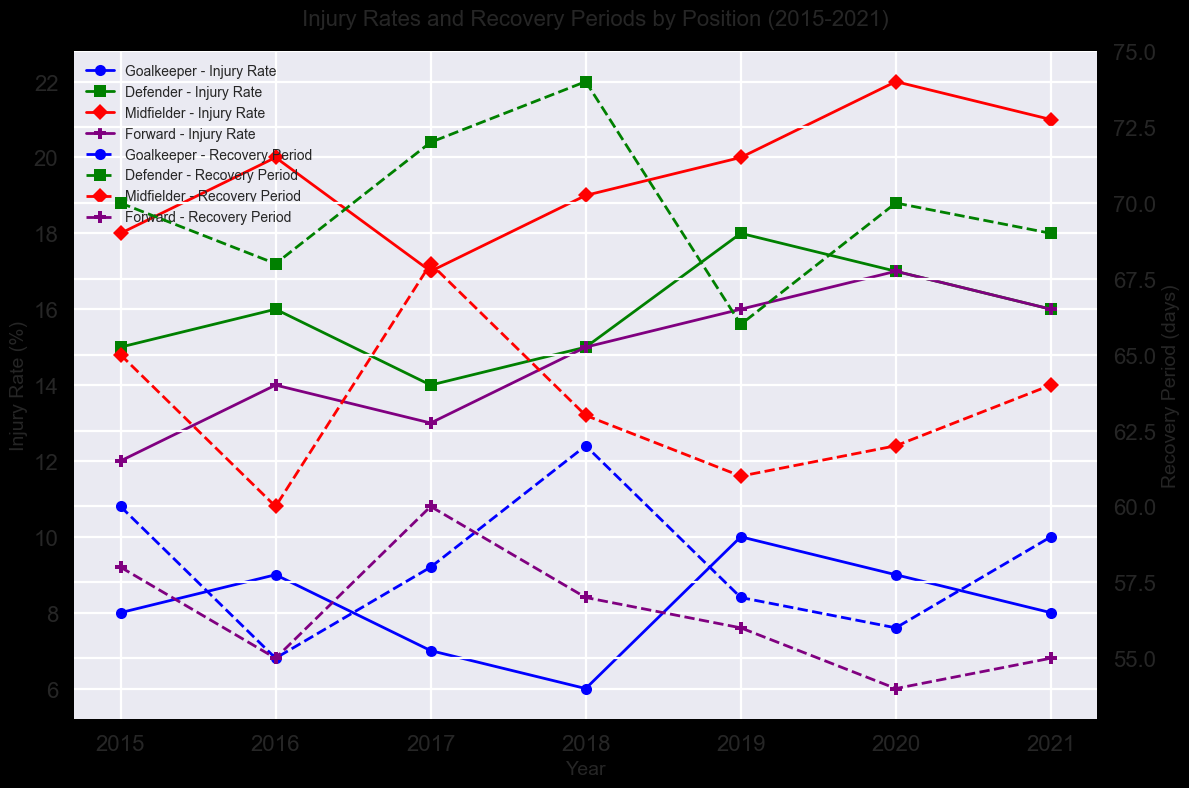What's the trend in the injury rate for goalkeepers from 2015 to 2021? Look at the plot lines for goalkeepers. From 2015 to 2021, the injury rate fluctuated but ultimately decreased from 8 in 2015 to 8 in 2021, with a peak of 10 in 2019.
Answer: Decreasing Which position had the highest recovery period in 2021? Compare the endpoints of the dashed lines for each position in the recovery period subplot in 2021. Midfielders had the highest recovery period, which is around 64 days.
Answer: Midfielder By how much did the injury rate of midfielders change from 2015 to 2021? Look at the injury rate for midfielders in 2015 and 2021. It was 18 in 2015 and 21 in 2021. The increase is 21 - 18 = 3.
Answer: 3 Comparing injury rates, which position had the most significant increase from 2015 to 2021? Analyze the difference between the injury rates of each position in 2021 and 2015. Forwards have the most significant increase (16 - 12 = 4).
Answer: Forward Which year had the lowest injury rate for goalkeepers, and what was it? Identify the lowest point in the goalkeeper injury rate line plot. The lowest was in 2018 with a value of 6.
Answer: 2018, 6 What's the average recovery period for defenders from 2015 to 2021? Calculate the average of the recovery periods for defenders across these years: (70 + 68 + 72 + 74 + 66 + 70 + 69) / 7 = 69.86.
Answer: 69.86 Did the recovery period for forwards increase or decrease between 2015 and 2021? Compare the endpoints of the forwards' recovery period line plot. The period decreased from 58 in 2015 to 55 in 2021.
Answer: Decrease Among all positions, which one had the smallest variance in injury rates over the years? Look at the fluctuation of the lines representing injury rates. Goalkeepers show the least fluctuation compared to others.
Answer: Goalkeeper When did midfielders experience their highest recovery period, and what was it? Identify the peak of the midfielder recovery period line. The highest was in 2017, with a value of 68 days.
Answer: 2017, 68 What's the difference between the maximum injury rate for defenders and forwards in the period from 2015 to 2021? Identify the maximum injury rates for defenders (18 in 2019) and forwards (17 in 2020). The difference 18 - 17 = 1.
Answer: 1 